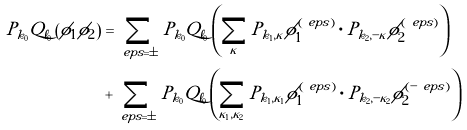Convert formula to latex. <formula><loc_0><loc_0><loc_500><loc_500>P _ { k _ { 0 } } Q _ { \ell _ { 0 } } \left ( \phi _ { 1 } \phi _ { 2 } \right ) & = \sum _ { \ e p s = \pm } P _ { k _ { 0 } } Q _ { \ell _ { 0 } } \left ( \sum _ { \kappa } P _ { k _ { 1 } , \kappa } \phi _ { 1 } ^ { ( \ e p s ) } \cdot P _ { k _ { 2 } , - \kappa } \phi _ { 2 } ^ { ( \ e p s ) } \right ) \\ & + \sum _ { \ e p s = \pm } P _ { k _ { 0 } } Q _ { \ell _ { 0 } } \left ( \sum _ { \kappa _ { 1 } , \kappa _ { 2 } } P _ { k _ { 1 } , \kappa _ { 1 } } \phi _ { 1 } ^ { ( \ e p s ) } \cdot P _ { k _ { 2 } , - \kappa _ { 2 } } \phi _ { 2 } ^ { ( - \ e p s ) } \right )</formula> 